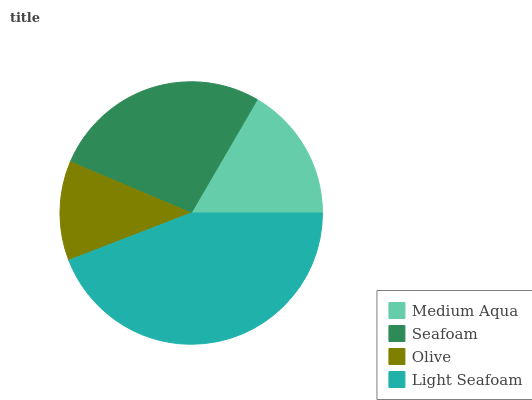Is Olive the minimum?
Answer yes or no. Yes. Is Light Seafoam the maximum?
Answer yes or no. Yes. Is Seafoam the minimum?
Answer yes or no. No. Is Seafoam the maximum?
Answer yes or no. No. Is Seafoam greater than Medium Aqua?
Answer yes or no. Yes. Is Medium Aqua less than Seafoam?
Answer yes or no. Yes. Is Medium Aqua greater than Seafoam?
Answer yes or no. No. Is Seafoam less than Medium Aqua?
Answer yes or no. No. Is Seafoam the high median?
Answer yes or no. Yes. Is Medium Aqua the low median?
Answer yes or no. Yes. Is Olive the high median?
Answer yes or no. No. Is Seafoam the low median?
Answer yes or no. No. 